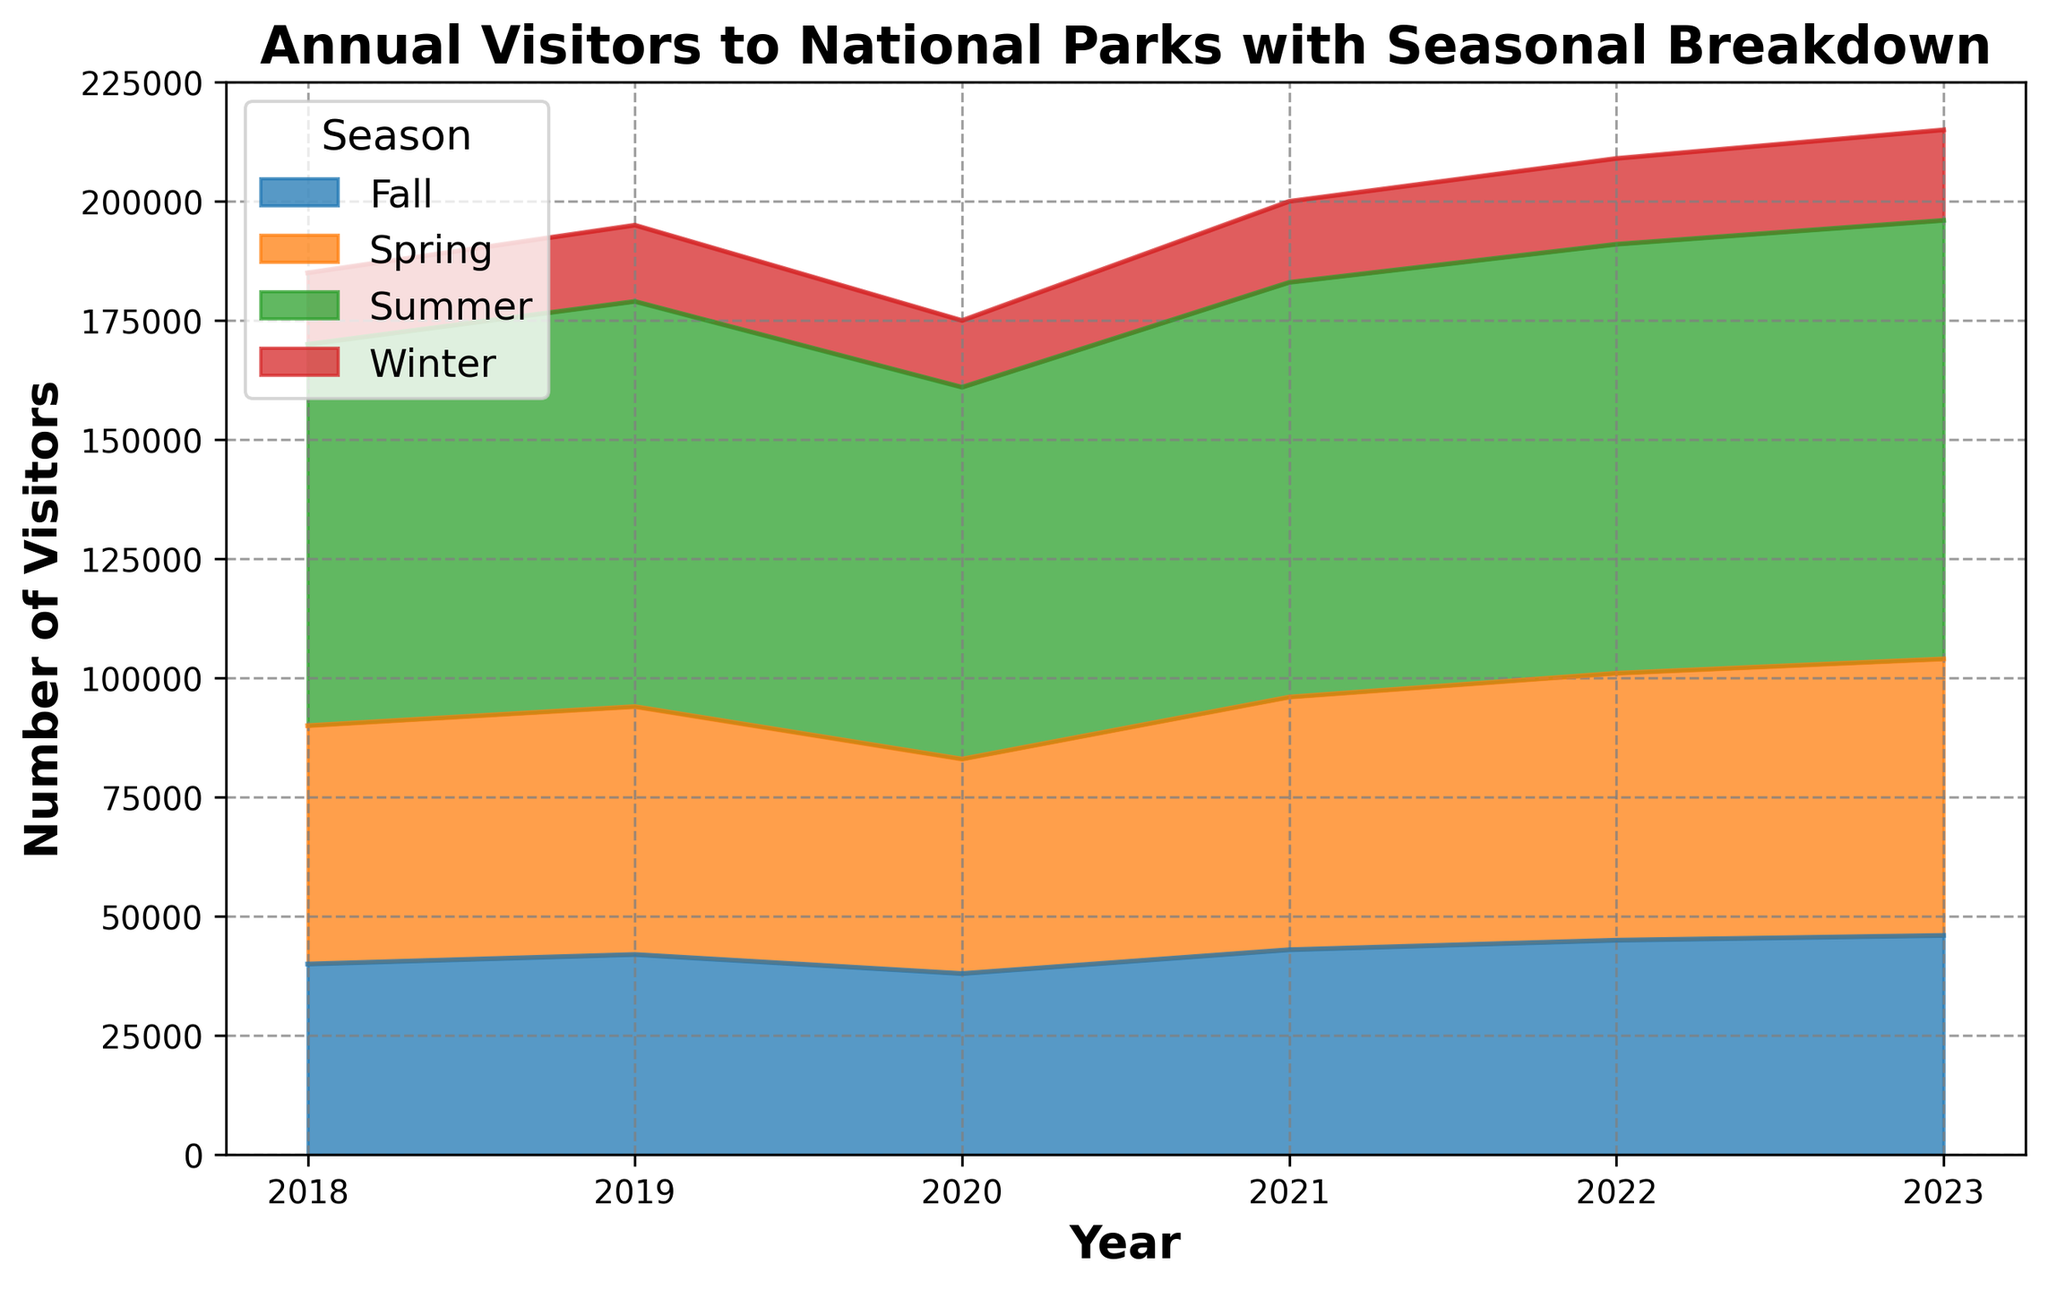What year had the highest total number of visitors to the national parks? To find the highest total number of visitors, sum up the visitors for each season in each year and compare. Total visitors in 2022 are 181,000, the highest among all years.
Answer: 2022 Which season consistently had the fewest visitors each year? Compare the visitor numbers for each season across all years. Winter always has the lowest number of visitors each year.
Answer: Winter By how much did the number of visitors in Spring 2023 exceed the number of visitors in Fall 2023? Subtract Fall 2023 visitors from Spring 2023 visitors: 58,000 - 46,000 = 12,000.
Answer: 12,000 Which year saw the highest number of visitors in Summer? Look for the year with the maximum value in the Summer row. 2023 had the highest summer visitors at 92,000.
Answer: 2023 How did the total number of visitors change from 2019 to 2020? Calculate the total visitors in 2019 (155,000) and 2020 (142,000) and find the difference: 155,000 - 142,000 = 13,000 less in 2020.
Answer: Decreased by 13,000 What was the average number of visitors per year in Fall? Calculate the average by summing Fall visitors across all years (264,000) and dividing by the number of years (6): 264,000 / 6 = 44,000.
Answer: 44,000 In which year did the Winter season see its highest number of visitors? Check the Winter column for the highest value, which is in 2023 with 19,000 visitors.
Answer: 2023 Is the trend of visitors in Summer increasing, decreasing, or stable over the years? Observe the Summer data points from 2018 to 2023. The sequence is generally increasing: 80,000, 85,000, 78,000, 87,000, 90,000, 92,000.
Answer: Increasing What is the total number of visitors to national parks in 2020, excluding Winter? Sum Spring, Summer, and Fall visitors for 2020: 45,000 + 78,000 + 38,000 = 161,000.
Answer: 161,000 